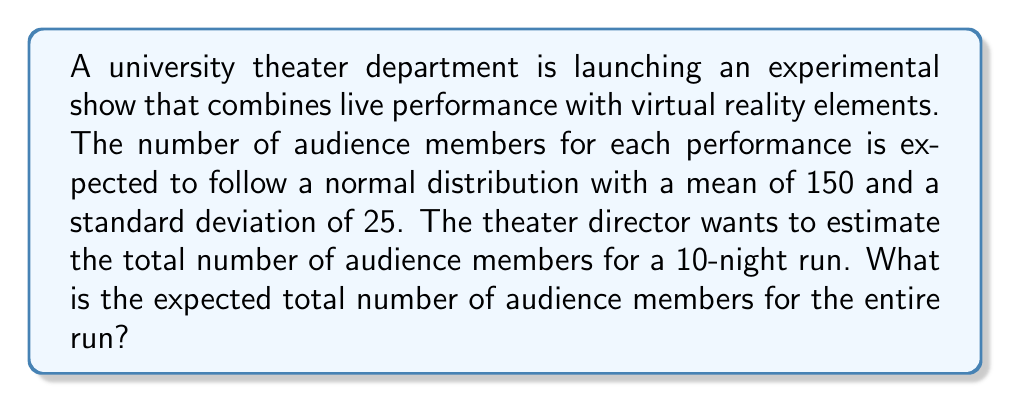Can you solve this math problem? Let's approach this step-by-step:

1) We are given that the number of audience members for each performance follows a normal distribution with:
   
   Mean (μ) = 150
   Standard deviation (σ) = 25

2) We need to find the expected total number of audience members for 10 nights.

3) Let X be the random variable representing the number of audience members for a single night. Then:

   $X \sim N(150, 25^2)$

4) Let Y be the random variable representing the total number of audience members for 10 nights. Y is the sum of 10 independent, identically distributed normal random variables.

5) A key property of normal distributions is that the sum of independent normal random variables is also normally distributed. The mean of the sum is the sum of the means, and the variance of the sum is the sum of the variances.

6) Therefore, for Y:

   Mean: $E(Y) = 10 \times 150 = 1500$
   
   Variance: $Var(Y) = 10 \times 25^2 = 6250$

7) However, we only need the expected value (mean) of Y, which is 1500.

The expected total number of audience members for the 10-night run is therefore 1500.
Answer: 1500 